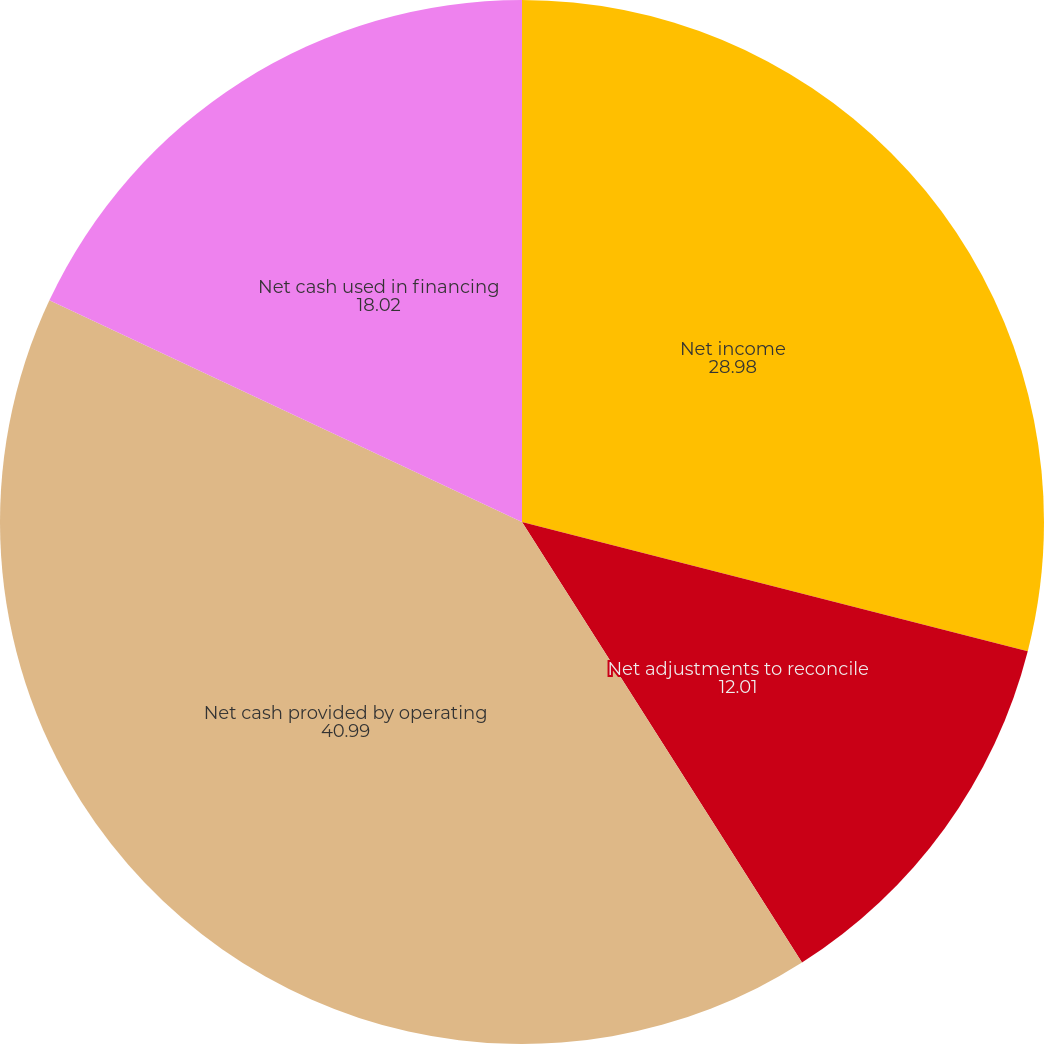Convert chart. <chart><loc_0><loc_0><loc_500><loc_500><pie_chart><fcel>Net income<fcel>Net adjustments to reconcile<fcel>Net cash provided by operating<fcel>Net cash used in financing<nl><fcel>28.98%<fcel>12.01%<fcel>40.99%<fcel>18.02%<nl></chart> 